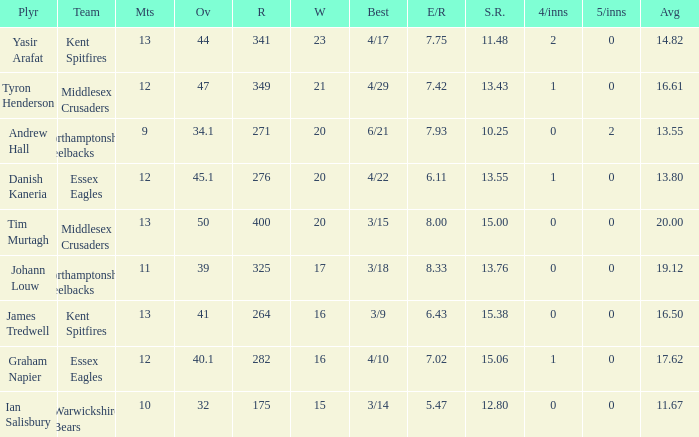Name the most wickets for best is 4/22 20.0. 